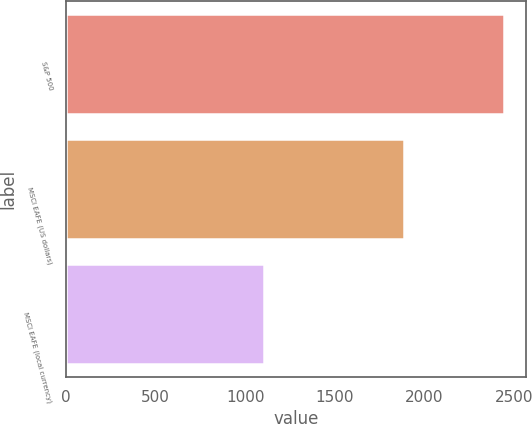<chart> <loc_0><loc_0><loc_500><loc_500><bar_chart><fcel>S&P 500<fcel>MSCI EAFE (US dollars)<fcel>MSCI EAFE (local currency)<nl><fcel>2448<fcel>1886<fcel>1105<nl></chart> 